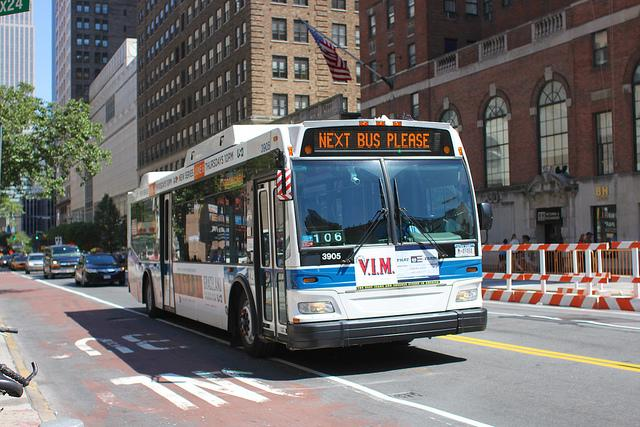Where does the bus go next? next stop 